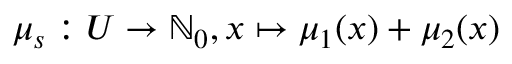<formula> <loc_0><loc_0><loc_500><loc_500>\mu _ { s } \colon U \rightarrow \mathbb { N } _ { 0 } , x \mapsto \mu _ { 1 } ( x ) + \mu _ { 2 } ( x )</formula> 